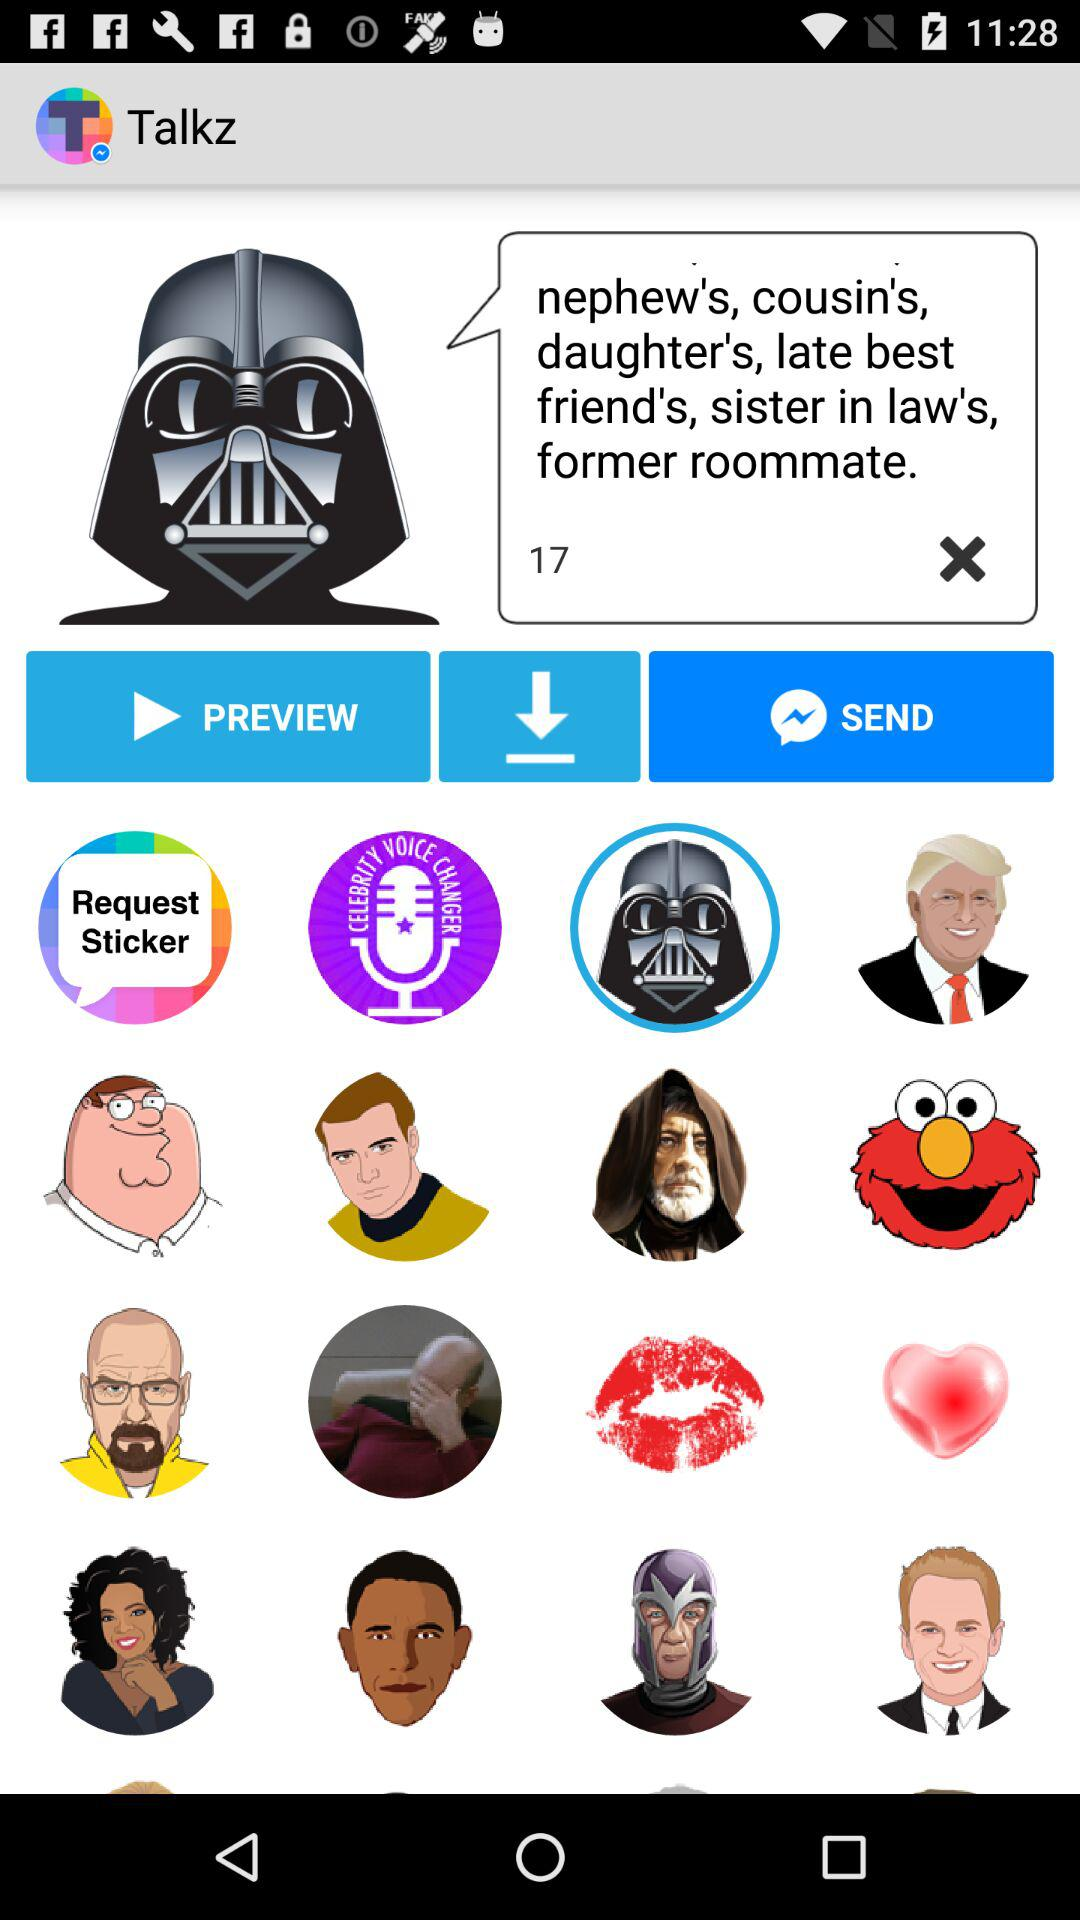What is the name of the application? The name of the application is "Talkz". 